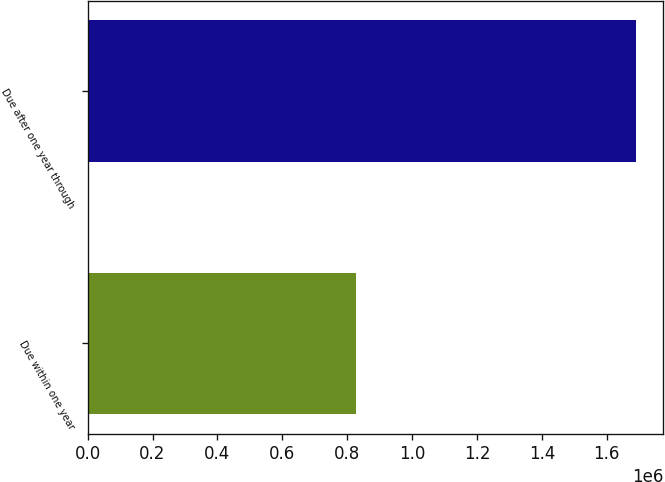Convert chart. <chart><loc_0><loc_0><loc_500><loc_500><bar_chart><fcel>Due within one year<fcel>Due after one year through<nl><fcel>827823<fcel>1.68975e+06<nl></chart> 